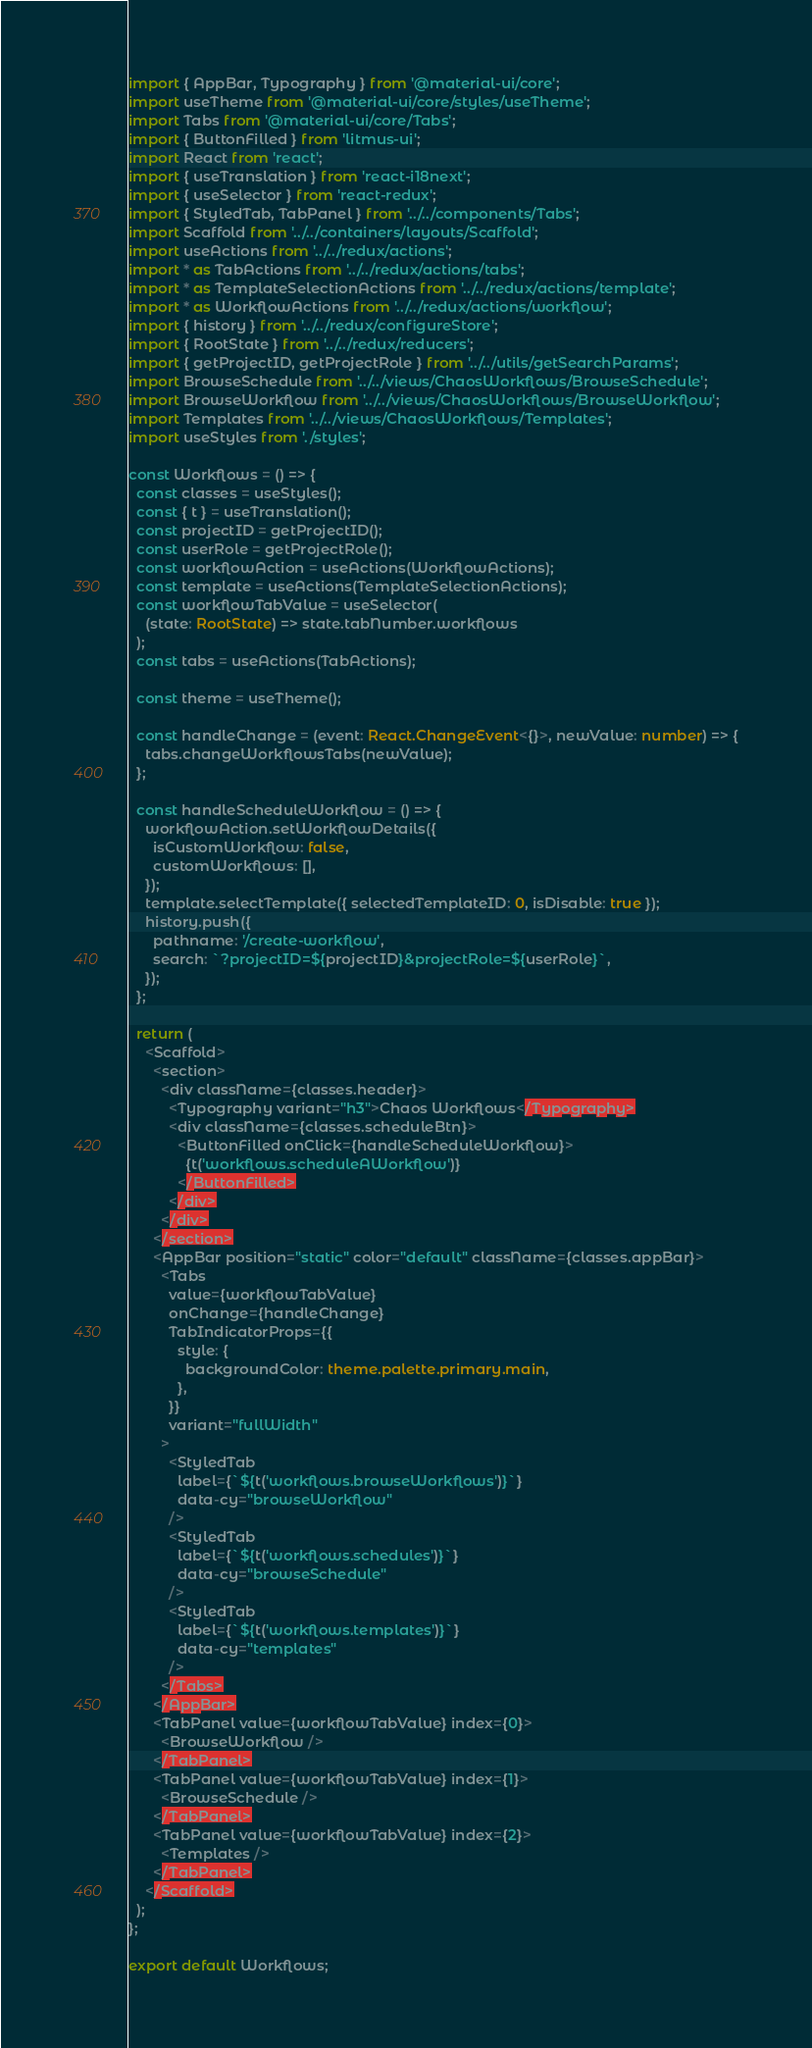Convert code to text. <code><loc_0><loc_0><loc_500><loc_500><_TypeScript_>import { AppBar, Typography } from '@material-ui/core';
import useTheme from '@material-ui/core/styles/useTheme';
import Tabs from '@material-ui/core/Tabs';
import { ButtonFilled } from 'litmus-ui';
import React from 'react';
import { useTranslation } from 'react-i18next';
import { useSelector } from 'react-redux';
import { StyledTab, TabPanel } from '../../components/Tabs';
import Scaffold from '../../containers/layouts/Scaffold';
import useActions from '../../redux/actions';
import * as TabActions from '../../redux/actions/tabs';
import * as TemplateSelectionActions from '../../redux/actions/template';
import * as WorkflowActions from '../../redux/actions/workflow';
import { history } from '../../redux/configureStore';
import { RootState } from '../../redux/reducers';
import { getProjectID, getProjectRole } from '../../utils/getSearchParams';
import BrowseSchedule from '../../views/ChaosWorkflows/BrowseSchedule';
import BrowseWorkflow from '../../views/ChaosWorkflows/BrowseWorkflow';
import Templates from '../../views/ChaosWorkflows/Templates';
import useStyles from './styles';

const Workflows = () => {
  const classes = useStyles();
  const { t } = useTranslation();
  const projectID = getProjectID();
  const userRole = getProjectRole();
  const workflowAction = useActions(WorkflowActions);
  const template = useActions(TemplateSelectionActions);
  const workflowTabValue = useSelector(
    (state: RootState) => state.tabNumber.workflows
  );
  const tabs = useActions(TabActions);

  const theme = useTheme();

  const handleChange = (event: React.ChangeEvent<{}>, newValue: number) => {
    tabs.changeWorkflowsTabs(newValue);
  };

  const handleScheduleWorkflow = () => {
    workflowAction.setWorkflowDetails({
      isCustomWorkflow: false,
      customWorkflows: [],
    });
    template.selectTemplate({ selectedTemplateID: 0, isDisable: true });
    history.push({
      pathname: '/create-workflow',
      search: `?projectID=${projectID}&projectRole=${userRole}`,
    });
  };

  return (
    <Scaffold>
      <section>
        <div className={classes.header}>
          <Typography variant="h3">Chaos Workflows</Typography>
          <div className={classes.scheduleBtn}>
            <ButtonFilled onClick={handleScheduleWorkflow}>
              {t('workflows.scheduleAWorkflow')}
            </ButtonFilled>
          </div>
        </div>
      </section>
      <AppBar position="static" color="default" className={classes.appBar}>
        <Tabs
          value={workflowTabValue}
          onChange={handleChange}
          TabIndicatorProps={{
            style: {
              backgroundColor: theme.palette.primary.main,
            },
          }}
          variant="fullWidth"
        >
          <StyledTab
            label={`${t('workflows.browseWorkflows')}`}
            data-cy="browseWorkflow"
          />
          <StyledTab
            label={`${t('workflows.schedules')}`}
            data-cy="browseSchedule"
          />
          <StyledTab
            label={`${t('workflows.templates')}`}
            data-cy="templates"
          />
        </Tabs>
      </AppBar>
      <TabPanel value={workflowTabValue} index={0}>
        <BrowseWorkflow />
      </TabPanel>
      <TabPanel value={workflowTabValue} index={1}>
        <BrowseSchedule />
      </TabPanel>
      <TabPanel value={workflowTabValue} index={2}>
        <Templates />
      </TabPanel>
    </Scaffold>
  );
};

export default Workflows;
</code> 